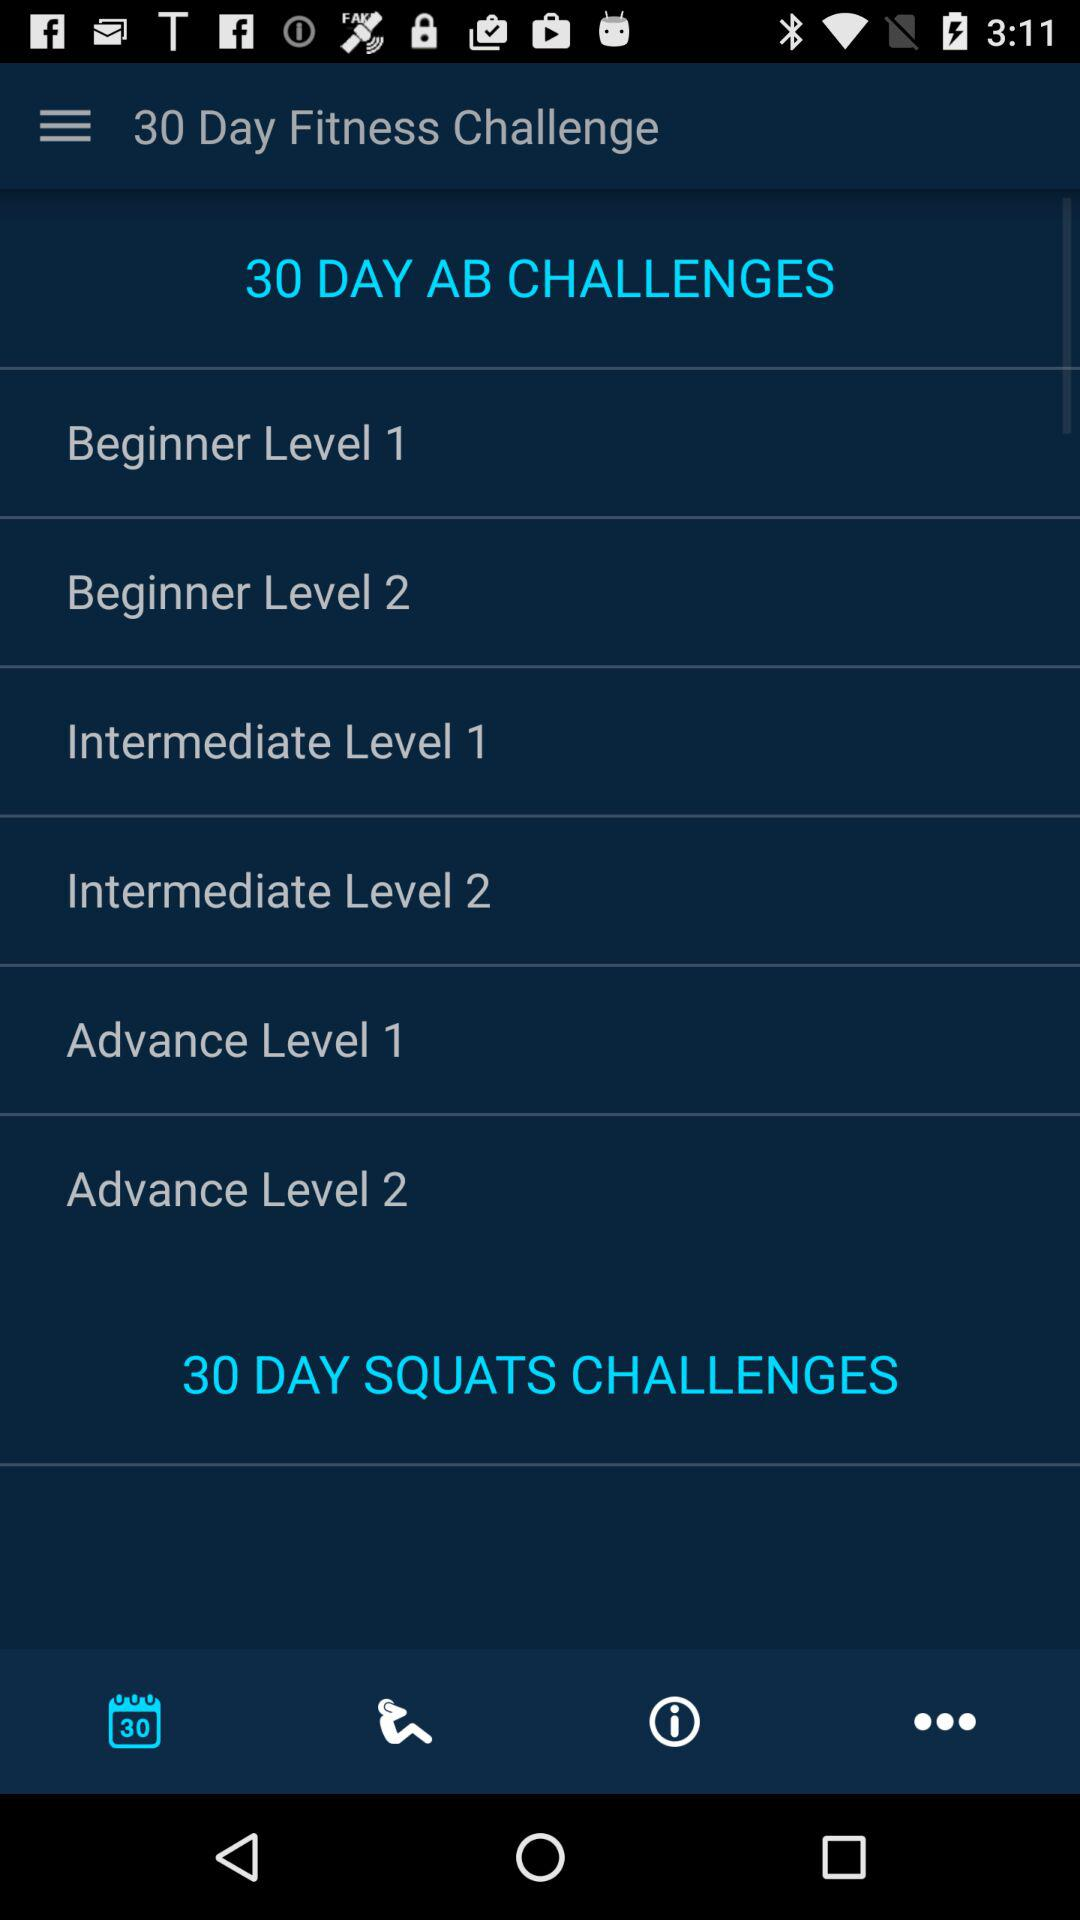How many levels are there in the Beginner category?
Answer the question using a single word or phrase. 2 